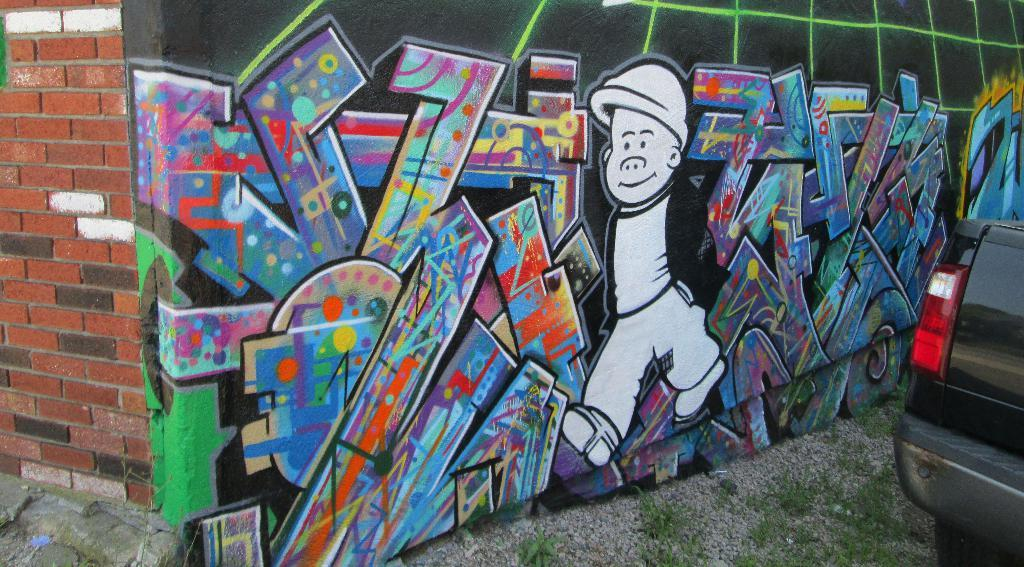What is depicted on the wall in the image? There are paintings on the wall in the image. What can be seen on the right side of the image? There is a vehicle on the right side of the image. Where is the vehicle located? The vehicle is on a road. What is present at the bottom of the image? There are plants and stones at the bottom of the image. What type of banana is hanging from the vehicle in the image? There is no banana present in the image, and therefore no such object can be observed. What color is the grass surrounding the vehicle in the image? There is no grass present in the image; it features a vehicle on a road and plants and stones at the bottom. 